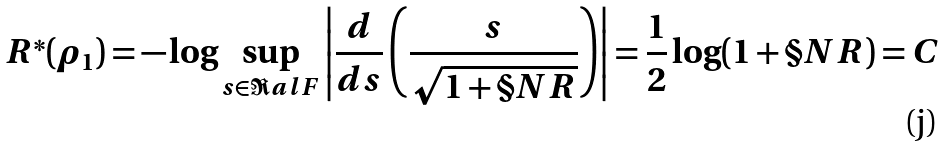<formula> <loc_0><loc_0><loc_500><loc_500>R ^ { * } ( \rho _ { 1 } ) = - \log \sup _ { s \in \Re a l F } \left | \frac { d } { d s } \left ( \frac { s } { \sqrt { 1 + \S N R } } \right ) \right | = \frac { 1 } { 2 } \log ( 1 + \S N R ) = C</formula> 